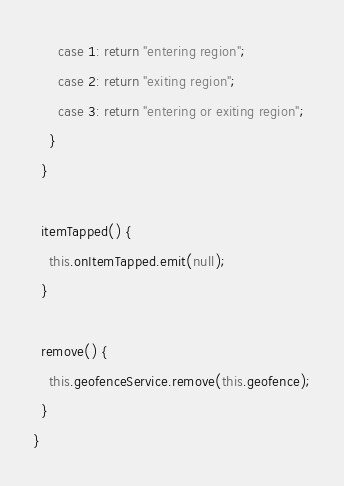Convert code to text. <code><loc_0><loc_0><loc_500><loc_500><_TypeScript_>      case 1: return "entering region";
      case 2: return "exiting region";
      case 3: return "entering or exiting region";
    }
  }

  itemTapped() {
    this.onItemTapped.emit(null);
  }

  remove() {
    this.geofenceService.remove(this.geofence);
  }
}
</code> 